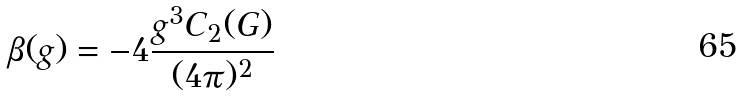Convert formula to latex. <formula><loc_0><loc_0><loc_500><loc_500>\beta ( g ) = - 4 \frac { g ^ { 3 } C _ { 2 } ( G ) } { ( 4 \pi ) ^ { 2 } }</formula> 